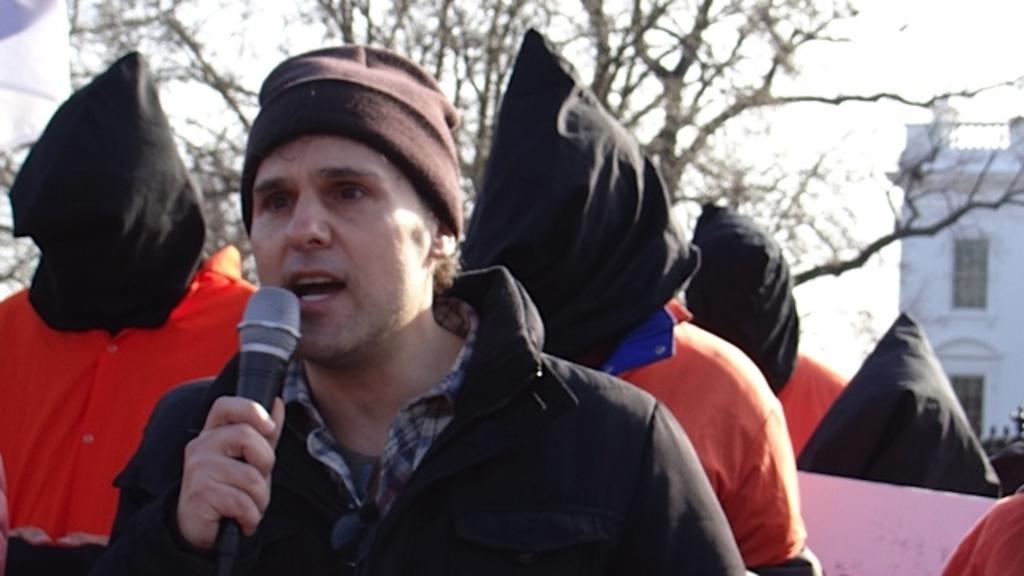How would you summarize this image in a sentence or two? In this image I can see a person wearing black jacket is holding a microphone in his hand and I can see he is wearing a cap. In the background I can see few other persons wearing orange colored dresses and black colored face masks to their head and I can see a tree, a building and the sky in the background. 